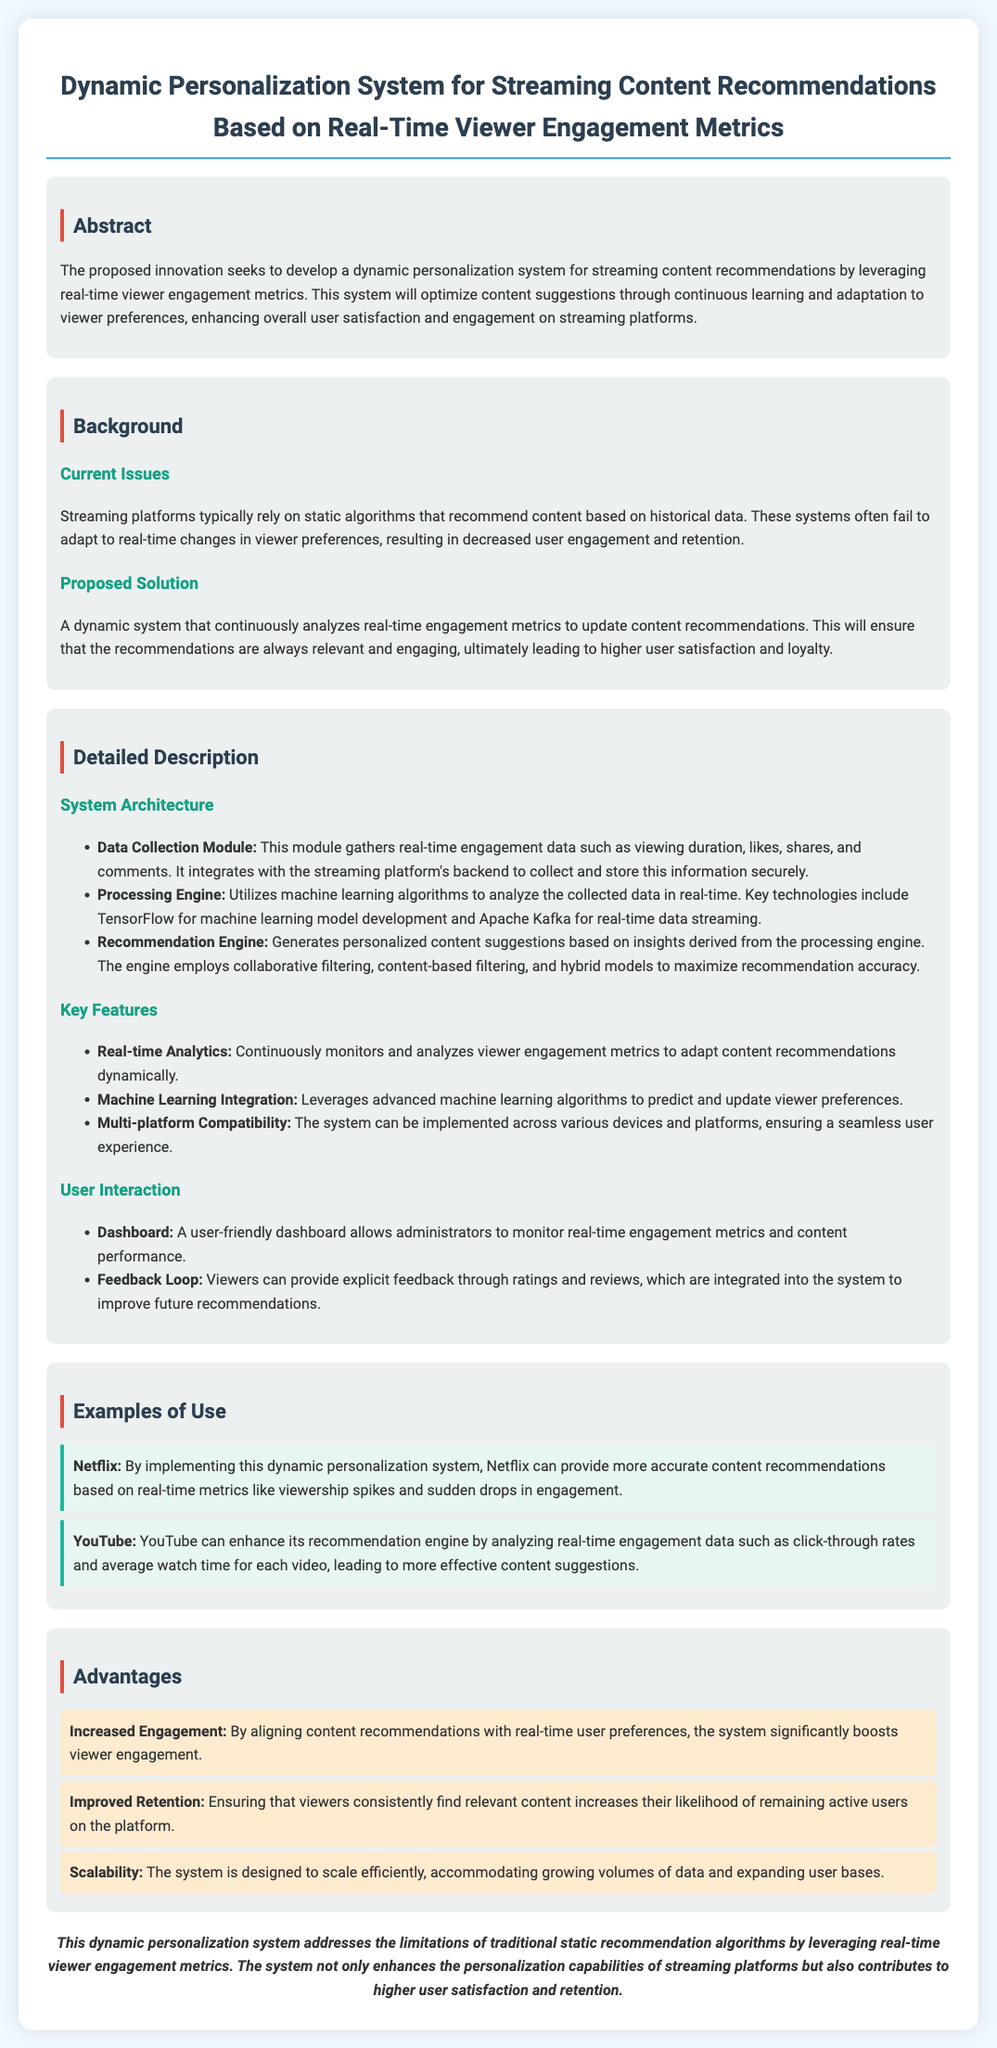What is the title of the document? The title of the document is mentioned at the beginning section and summarizes the main innovation discussed.
Answer: Dynamic Personalization System for Streaming Content Recommendations Based on Real-Time Viewer Engagement Metrics What is the purpose of the proposed system? The purpose is outlined in the abstract, describing the intent to develop a system for content recommendations.
Answer: Enhance overall user satisfaction and engagement on streaming platforms What technologies are mentioned in the Processing Engine? The specific technologies utilized in the Processing Engine are listed to highlight the technical aspects of the system.
Answer: TensorFlow and Apache Kafka What type of feedback mechanism is included in user interaction? The document describes how viewers can engage with the system to improve future recommendations.
Answer: Feedback Loop What is one key advantage of this system? The advantages are outlined in a section, highlighting the benefits to the streaming platforms.
Answer: Increased Engagement How does the proposed system improve retention? The explanation is found in the advantages section regarding its impact on user behavior.
Answer: Ensuring that viewers consistently find relevant content Which platform example uses the dynamic personalization system? The document provides examples of platforms that could utilize the proposed system for effectiveness.
Answer: Netflix What is the main limitation that the system addresses? This is stated in the background section, referring to the challenges faced by current recommendation algorithms.
Answer: Limitations of traditional static recommendation algorithms 